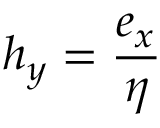Convert formula to latex. <formula><loc_0><loc_0><loc_500><loc_500>h _ { y } = { \frac { e _ { x } } { \eta } }</formula> 